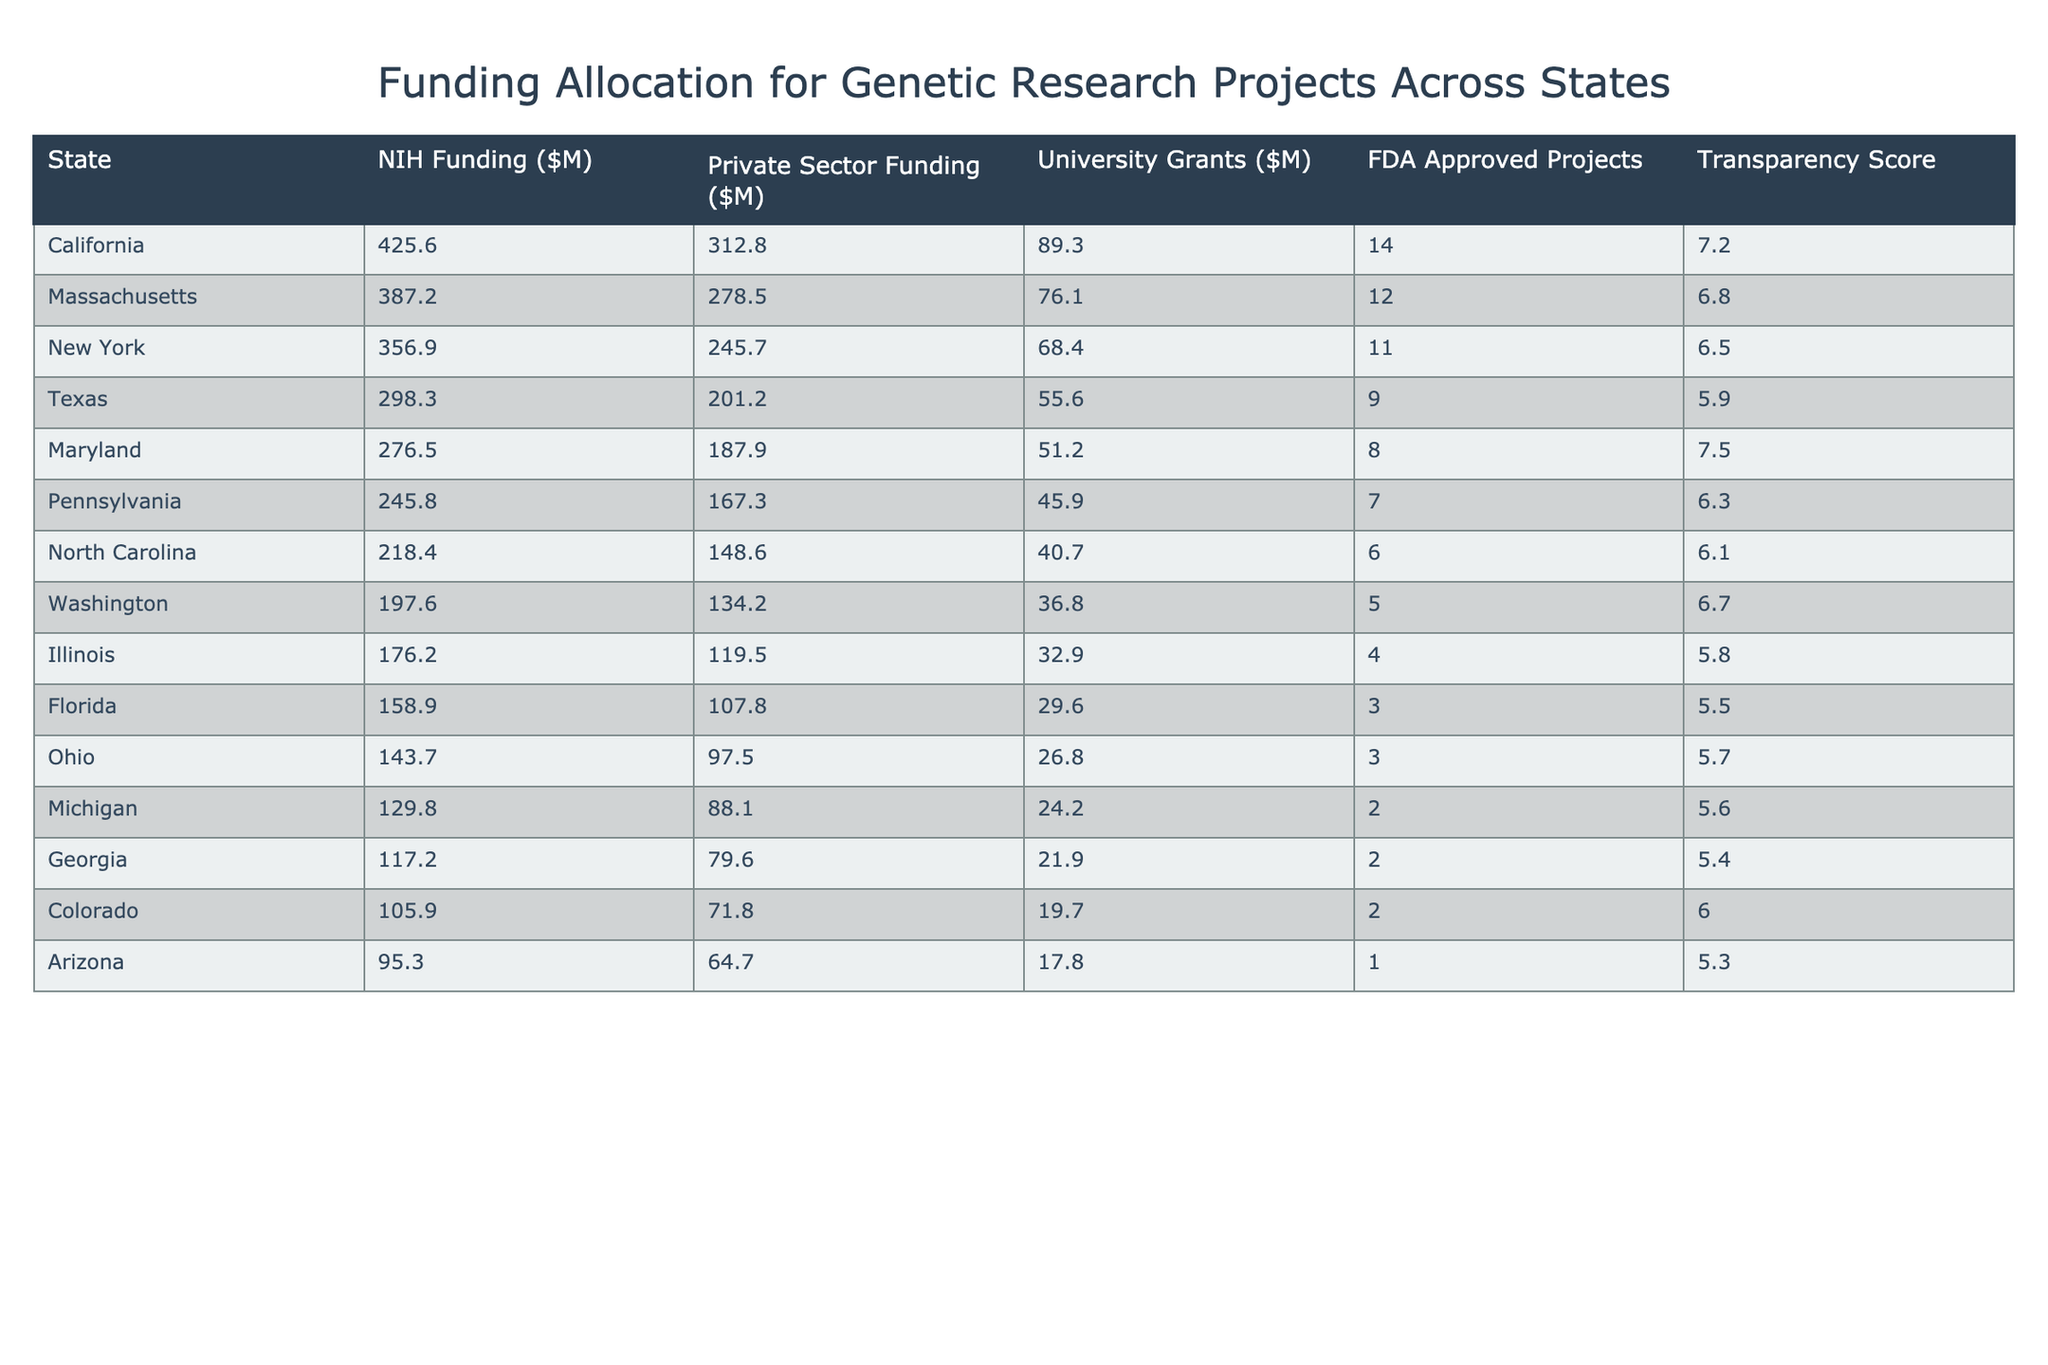What state received the highest NIH funding? By examining the NIH Funding column, we see that California has the highest value listed at 425.6 million dollars.
Answer: California How much private sector funding did Texas receive? Looking at the Private Sector Funding column, Texas shows a value of 201.2 million dollars.
Answer: 201.2 million Which state has the lowest total funding (NIH + Private Sector + University Grants)? First, we calculate the total for each state. Arizona has 95.3 (NIH) + 64.7 (Private Sector) + 17.8 (University Grants) = 177.8 million dollars, which is the lowest total funding.
Answer: Arizona What is the total funding for Massachusetts? For Massachusetts, we sum the values: NIH Funding 387.2 million + Private Sector Funding 278.5 million + University Grants 76.1 million = 741.8 million dollars.
Answer: 741.8 million Which state has the highest number of FDA Approved Projects? By comparing the FDA Approved Projects column, we find California has the highest value with 14 approved projects.
Answer: California Is there a state with a Transparency Score higher than 7.0? Yes, both California (7.2) and Maryland (7.5) have Transparency Scores higher than 7.0.
Answer: Yes How does the average Transparency Score of states with FDA Approved Projects compare to those without? First, we calculate the average Transparency Score for states with FDA Approved Projects: (7.2 + 6.8 + 6.5 + 5.9 + 7.5 + 6.3 + 6.1 + 6.7 + 5.8 + 5.5 + 5.7 + 5.6 + 5.4 + 6.0 + 5.3) / 15 = 6.06, whereas states without FDA Approved Projects do not exist, so they do not affect the calculation. Thus, we only have the first group for comparison.
Answer: 6.06 (only FDA Approved Projects) What is the difference in total funding between California and Ohio? For California, total funding is 425.6 (NIH) + 312.8 (Private Sector) + 89.3 (University Grants) = 827.7 million. For Ohio, it is 143.7 + 97.5 + 26.8 = 268 million. The difference is 827.7 - 268 = 559.7 million.
Answer: 559.7 million Which state to receive funding from the university grants is closest to 30 million dollars? Looking at the University Grants column, we see that Florida has 29.6 million, which is the closest to 30 million.
Answer: Florida If we combine NIH funding and private sector funding, which state has the highest combined amount? We calculate combined funding: California (738.4), Massachusetts (665.7), New York (602.6), Texas (499.5), etc. California has the highest combined amount at 738.4 million dollars.
Answer: California How many states received an FDA Approved Project count of 3 or less? We check the FDA Approved Projects column and see that Florida (3), Ohio (3), Michigan (2), Georgia (2), Colorado (2), and Arizona (1) fit this criterion, totaling 6 states.
Answer: 6 states 